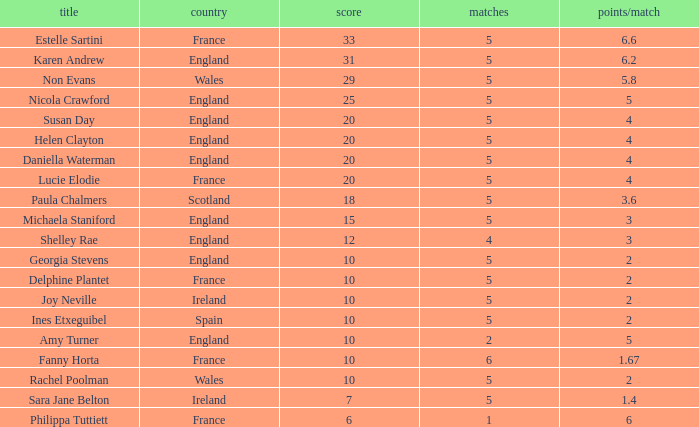Can you tell me the lowest Pts/game that has the Name of philippa tuttiett, and the Points larger then 6? None. 